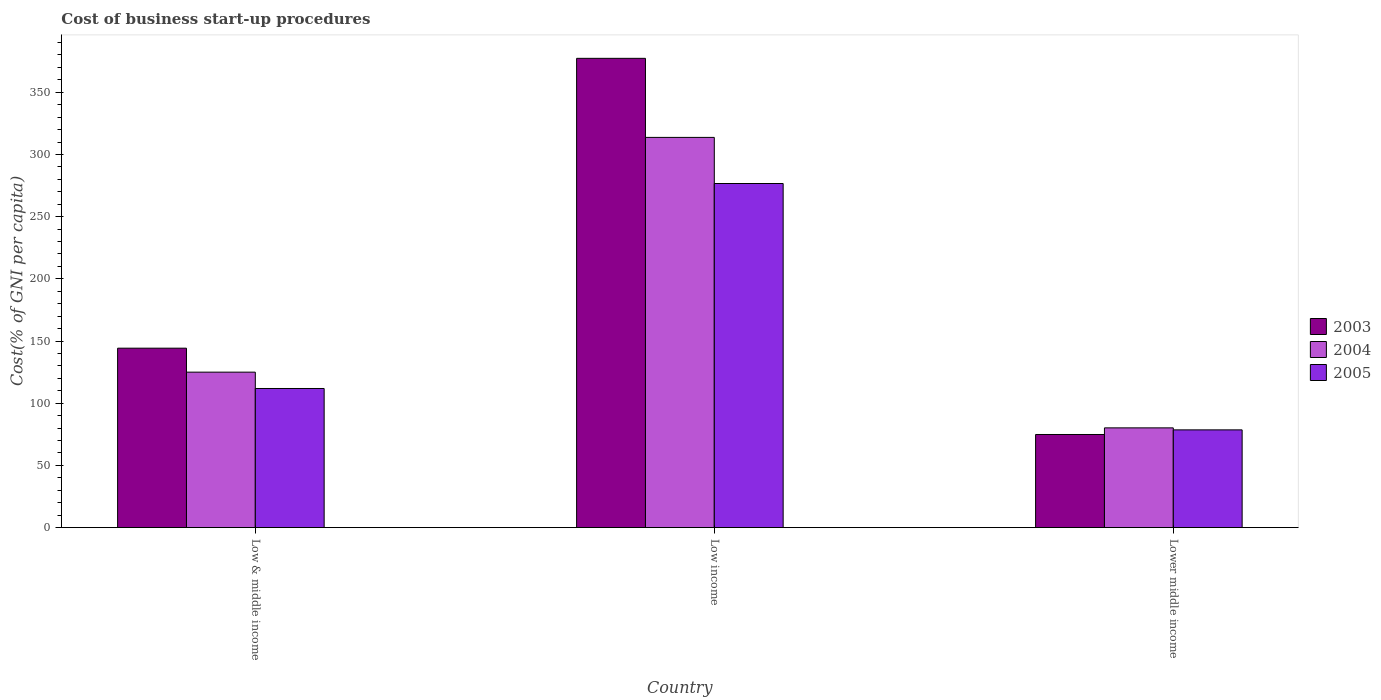How many different coloured bars are there?
Provide a succinct answer. 3. Are the number of bars on each tick of the X-axis equal?
Your answer should be compact. Yes. What is the label of the 3rd group of bars from the left?
Your answer should be very brief. Lower middle income. In how many cases, is the number of bars for a given country not equal to the number of legend labels?
Offer a very short reply. 0. What is the cost of business start-up procedures in 2005 in Lower middle income?
Your answer should be compact. 78.58. Across all countries, what is the maximum cost of business start-up procedures in 2005?
Keep it short and to the point. 276.64. Across all countries, what is the minimum cost of business start-up procedures in 2005?
Make the answer very short. 78.58. In which country was the cost of business start-up procedures in 2005 minimum?
Your response must be concise. Lower middle income. What is the total cost of business start-up procedures in 2004 in the graph?
Offer a terse response. 518.89. What is the difference between the cost of business start-up procedures in 2004 in Low & middle income and that in Low income?
Make the answer very short. -188.73. What is the difference between the cost of business start-up procedures in 2004 in Low & middle income and the cost of business start-up procedures in 2003 in Lower middle income?
Keep it short and to the point. 50.11. What is the average cost of business start-up procedures in 2005 per country?
Offer a terse response. 155.69. What is the difference between the cost of business start-up procedures of/in 2003 and cost of business start-up procedures of/in 2005 in Lower middle income?
Offer a terse response. -3.71. In how many countries, is the cost of business start-up procedures in 2003 greater than 210 %?
Your answer should be very brief. 1. What is the ratio of the cost of business start-up procedures in 2005 in Low & middle income to that in Lower middle income?
Keep it short and to the point. 1.42. What is the difference between the highest and the second highest cost of business start-up procedures in 2003?
Offer a terse response. -233.01. What is the difference between the highest and the lowest cost of business start-up procedures in 2003?
Keep it short and to the point. 302.39. What does the 1st bar from the left in Lower middle income represents?
Your answer should be very brief. 2003. How many bars are there?
Ensure brevity in your answer.  9. Are the values on the major ticks of Y-axis written in scientific E-notation?
Offer a terse response. No. Does the graph contain any zero values?
Your answer should be very brief. No. Does the graph contain grids?
Provide a succinct answer. No. What is the title of the graph?
Provide a succinct answer. Cost of business start-up procedures. Does "1985" appear as one of the legend labels in the graph?
Offer a very short reply. No. What is the label or title of the X-axis?
Offer a terse response. Country. What is the label or title of the Y-axis?
Provide a short and direct response. Cost(% of GNI per capita). What is the Cost(% of GNI per capita) in 2003 in Low & middle income?
Keep it short and to the point. 144.26. What is the Cost(% of GNI per capita) in 2004 in Low & middle income?
Provide a short and direct response. 124.99. What is the Cost(% of GNI per capita) of 2005 in Low & middle income?
Give a very brief answer. 111.86. What is the Cost(% of GNI per capita) of 2003 in Low income?
Give a very brief answer. 377.27. What is the Cost(% of GNI per capita) of 2004 in Low income?
Your answer should be very brief. 313.71. What is the Cost(% of GNI per capita) of 2005 in Low income?
Provide a succinct answer. 276.64. What is the Cost(% of GNI per capita) of 2003 in Lower middle income?
Offer a very short reply. 74.88. What is the Cost(% of GNI per capita) in 2004 in Lower middle income?
Provide a succinct answer. 80.19. What is the Cost(% of GNI per capita) of 2005 in Lower middle income?
Offer a very short reply. 78.58. Across all countries, what is the maximum Cost(% of GNI per capita) of 2003?
Give a very brief answer. 377.27. Across all countries, what is the maximum Cost(% of GNI per capita) of 2004?
Offer a very short reply. 313.71. Across all countries, what is the maximum Cost(% of GNI per capita) of 2005?
Your response must be concise. 276.64. Across all countries, what is the minimum Cost(% of GNI per capita) of 2003?
Your response must be concise. 74.88. Across all countries, what is the minimum Cost(% of GNI per capita) of 2004?
Offer a very short reply. 80.19. Across all countries, what is the minimum Cost(% of GNI per capita) in 2005?
Ensure brevity in your answer.  78.58. What is the total Cost(% of GNI per capita) in 2003 in the graph?
Give a very brief answer. 596.41. What is the total Cost(% of GNI per capita) of 2004 in the graph?
Make the answer very short. 518.89. What is the total Cost(% of GNI per capita) of 2005 in the graph?
Offer a terse response. 467.08. What is the difference between the Cost(% of GNI per capita) of 2003 in Low & middle income and that in Low income?
Your answer should be compact. -233.01. What is the difference between the Cost(% of GNI per capita) in 2004 in Low & middle income and that in Low income?
Provide a succinct answer. -188.73. What is the difference between the Cost(% of GNI per capita) of 2005 in Low & middle income and that in Low income?
Your answer should be compact. -164.79. What is the difference between the Cost(% of GNI per capita) of 2003 in Low & middle income and that in Lower middle income?
Ensure brevity in your answer.  69.39. What is the difference between the Cost(% of GNI per capita) of 2004 in Low & middle income and that in Lower middle income?
Your response must be concise. 44.79. What is the difference between the Cost(% of GNI per capita) of 2005 in Low & middle income and that in Lower middle income?
Keep it short and to the point. 33.27. What is the difference between the Cost(% of GNI per capita) in 2003 in Low income and that in Lower middle income?
Keep it short and to the point. 302.39. What is the difference between the Cost(% of GNI per capita) in 2004 in Low income and that in Lower middle income?
Make the answer very short. 233.52. What is the difference between the Cost(% of GNI per capita) of 2005 in Low income and that in Lower middle income?
Offer a terse response. 198.06. What is the difference between the Cost(% of GNI per capita) in 2003 in Low & middle income and the Cost(% of GNI per capita) in 2004 in Low income?
Your response must be concise. -169.45. What is the difference between the Cost(% of GNI per capita) of 2003 in Low & middle income and the Cost(% of GNI per capita) of 2005 in Low income?
Your response must be concise. -132.38. What is the difference between the Cost(% of GNI per capita) of 2004 in Low & middle income and the Cost(% of GNI per capita) of 2005 in Low income?
Your response must be concise. -151.65. What is the difference between the Cost(% of GNI per capita) in 2003 in Low & middle income and the Cost(% of GNI per capita) in 2004 in Lower middle income?
Give a very brief answer. 64.07. What is the difference between the Cost(% of GNI per capita) of 2003 in Low & middle income and the Cost(% of GNI per capita) of 2005 in Lower middle income?
Your response must be concise. 65.68. What is the difference between the Cost(% of GNI per capita) of 2004 in Low & middle income and the Cost(% of GNI per capita) of 2005 in Lower middle income?
Make the answer very short. 46.4. What is the difference between the Cost(% of GNI per capita) in 2003 in Low income and the Cost(% of GNI per capita) in 2004 in Lower middle income?
Keep it short and to the point. 297.08. What is the difference between the Cost(% of GNI per capita) of 2003 in Low income and the Cost(% of GNI per capita) of 2005 in Lower middle income?
Provide a succinct answer. 298.68. What is the difference between the Cost(% of GNI per capita) of 2004 in Low income and the Cost(% of GNI per capita) of 2005 in Lower middle income?
Your answer should be very brief. 235.13. What is the average Cost(% of GNI per capita) of 2003 per country?
Make the answer very short. 198.8. What is the average Cost(% of GNI per capita) of 2004 per country?
Your answer should be very brief. 172.96. What is the average Cost(% of GNI per capita) in 2005 per country?
Offer a very short reply. 155.69. What is the difference between the Cost(% of GNI per capita) in 2003 and Cost(% of GNI per capita) in 2004 in Low & middle income?
Offer a very short reply. 19.28. What is the difference between the Cost(% of GNI per capita) of 2003 and Cost(% of GNI per capita) of 2005 in Low & middle income?
Your answer should be very brief. 32.41. What is the difference between the Cost(% of GNI per capita) in 2004 and Cost(% of GNI per capita) in 2005 in Low & middle income?
Make the answer very short. 13.13. What is the difference between the Cost(% of GNI per capita) in 2003 and Cost(% of GNI per capita) in 2004 in Low income?
Give a very brief answer. 63.56. What is the difference between the Cost(% of GNI per capita) of 2003 and Cost(% of GNI per capita) of 2005 in Low income?
Ensure brevity in your answer.  100.63. What is the difference between the Cost(% of GNI per capita) of 2004 and Cost(% of GNI per capita) of 2005 in Low income?
Provide a succinct answer. 37.07. What is the difference between the Cost(% of GNI per capita) in 2003 and Cost(% of GNI per capita) in 2004 in Lower middle income?
Offer a very short reply. -5.32. What is the difference between the Cost(% of GNI per capita) of 2003 and Cost(% of GNI per capita) of 2005 in Lower middle income?
Make the answer very short. -3.71. What is the difference between the Cost(% of GNI per capita) in 2004 and Cost(% of GNI per capita) in 2005 in Lower middle income?
Offer a terse response. 1.61. What is the ratio of the Cost(% of GNI per capita) in 2003 in Low & middle income to that in Low income?
Your response must be concise. 0.38. What is the ratio of the Cost(% of GNI per capita) in 2004 in Low & middle income to that in Low income?
Give a very brief answer. 0.4. What is the ratio of the Cost(% of GNI per capita) in 2005 in Low & middle income to that in Low income?
Give a very brief answer. 0.4. What is the ratio of the Cost(% of GNI per capita) of 2003 in Low & middle income to that in Lower middle income?
Make the answer very short. 1.93. What is the ratio of the Cost(% of GNI per capita) of 2004 in Low & middle income to that in Lower middle income?
Offer a very short reply. 1.56. What is the ratio of the Cost(% of GNI per capita) in 2005 in Low & middle income to that in Lower middle income?
Make the answer very short. 1.42. What is the ratio of the Cost(% of GNI per capita) of 2003 in Low income to that in Lower middle income?
Give a very brief answer. 5.04. What is the ratio of the Cost(% of GNI per capita) of 2004 in Low income to that in Lower middle income?
Offer a terse response. 3.91. What is the ratio of the Cost(% of GNI per capita) in 2005 in Low income to that in Lower middle income?
Ensure brevity in your answer.  3.52. What is the difference between the highest and the second highest Cost(% of GNI per capita) in 2003?
Ensure brevity in your answer.  233.01. What is the difference between the highest and the second highest Cost(% of GNI per capita) of 2004?
Keep it short and to the point. 188.73. What is the difference between the highest and the second highest Cost(% of GNI per capita) in 2005?
Make the answer very short. 164.79. What is the difference between the highest and the lowest Cost(% of GNI per capita) of 2003?
Offer a terse response. 302.39. What is the difference between the highest and the lowest Cost(% of GNI per capita) in 2004?
Give a very brief answer. 233.52. What is the difference between the highest and the lowest Cost(% of GNI per capita) in 2005?
Your answer should be compact. 198.06. 